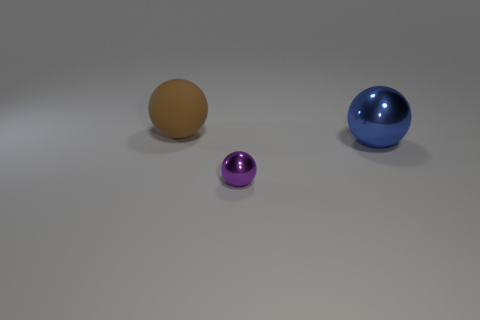Are there any other things that have the same material as the brown sphere?
Give a very brief answer. No. Is the number of small purple objects that are left of the brown thing the same as the number of matte balls that are behind the tiny shiny ball?
Ensure brevity in your answer.  No. How big is the metallic object in front of the large metal sphere?
Your answer should be compact. Small. What material is the thing that is in front of the large thing right of the tiny purple metal object?
Ensure brevity in your answer.  Metal. There is a metal thing that is on the left side of the big ball right of the tiny thing; what number of brown rubber things are on the right side of it?
Provide a short and direct response. 0. Is the sphere that is in front of the blue shiny sphere made of the same material as the large sphere to the right of the brown matte thing?
Keep it short and to the point. Yes. What number of cyan matte things have the same shape as the large blue object?
Provide a succinct answer. 0. Are there more big matte spheres that are to the left of the blue object than small yellow rubber cylinders?
Offer a very short reply. Yes. What shape is the metallic object left of the big thing that is right of the ball in front of the big blue object?
Your answer should be very brief. Sphere. Are there any other things that have the same size as the purple object?
Your answer should be compact. No. 